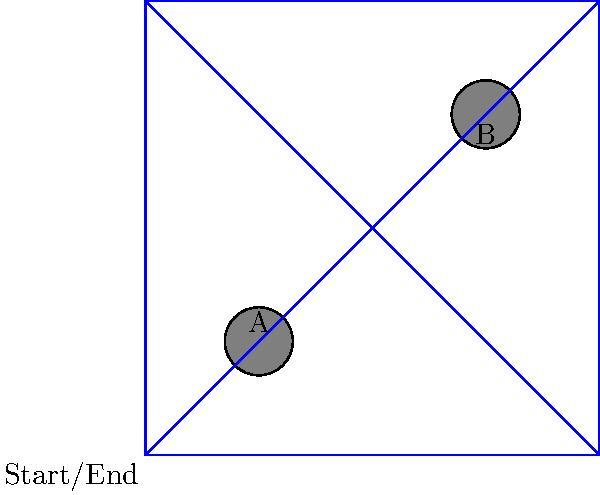Consider a morning jog around a square city block represented by a topological space. The block has two obstacles, A and B, as shown in the diagram. How many topologically distinct paths can you take to complete a lap around the block, starting and ending at the bottom-left corner, without crossing your path or touching the obstacles? Let's approach this step-by-step:

1) First, we need to understand what "topologically distinct" means in this context. Two paths are considered topologically distinct if one cannot be continuously deformed into the other without crossing an obstacle or the boundary of the block.

2) Now, let's consider the possible paths:

   a) The path that goes around the entire perimeter of the block.
   b) The path that goes diagonally from bottom-left to top-right, then around the top and right sides.
   c) The path that goes around the left and top sides, then diagonally from top-right to bottom-left.
   d) The path that goes between the obstacles, curving around obstacle A, then completing the lap.
   e) The path that goes between the obstacles, curving around obstacle B, then completing the lap.

3) Each of these paths cannot be continuously deformed into any of the others without either crossing an obstacle or the boundary of the block.

4) Therefore, each of these paths represents a topologically distinct route around the block.

5) Counting these paths, we find that there are 5 topologically distinct paths.
Answer: 5 